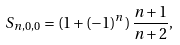<formula> <loc_0><loc_0><loc_500><loc_500>S _ { n , 0 , 0 } = ( 1 + ( - 1 ) ^ { n } ) \, \frac { n + 1 } { n + 2 } ,</formula> 